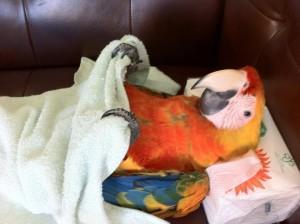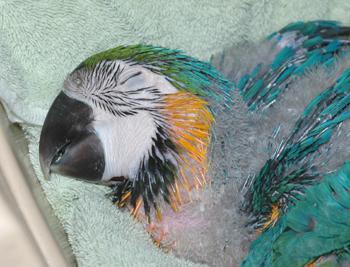The first image is the image on the left, the second image is the image on the right. Analyze the images presented: Is the assertion "All of the birds are outside." valid? Answer yes or no. No. The first image is the image on the left, the second image is the image on the right. Analyze the images presented: Is the assertion "Each image contains a single parrot, and each parrot has its eye squeezed tightly shut." valid? Answer yes or no. No. 